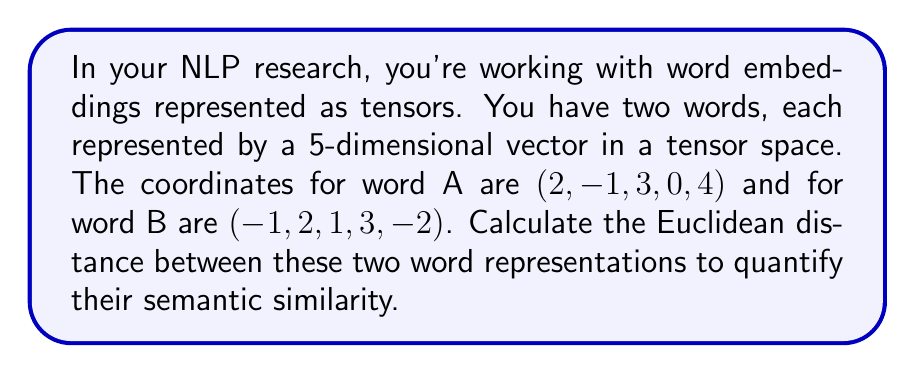Give your solution to this math problem. To solve this problem, we'll use the Euclidean distance formula for n-dimensional space. The formula is:

$$d = \sqrt{\sum_{i=1}^n (a_i - b_i)^2}$$

Where $a_i$ and $b_i$ are the coordinates of the two points in the $i$-th dimension.

Let's break it down step by step:

1) First, we'll calculate the differences between corresponding coordinates:
   Dimension 1: $2 - (-1) = 3$
   Dimension 2: $-1 - 2 = -3$
   Dimension 3: $3 - 1 = 2$
   Dimension 4: $0 - 3 = -3$
   Dimension 5: $4 - (-2) = 6$

2) Now, we'll square each of these differences:
   $3^2 = 9$
   $(-3)^2 = 9$
   $2^2 = 4$
   $(-3)^2 = 9$
   $6^2 = 36$

3) Next, we'll sum up all these squared differences:
   $9 + 9 + 4 + 9 + 36 = 67$

4) Finally, we'll take the square root of this sum:
   $\sqrt{67}$

Therefore, the Euclidean distance between the two word representations is $\sqrt{67}$.
Answer: $\sqrt{67}$ (approximately 8.185) 